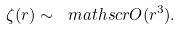Convert formula to latex. <formula><loc_0><loc_0><loc_500><loc_500>\zeta ( r ) \sim \ m a t h s c r { O } ( r ^ { 3 } ) .</formula> 